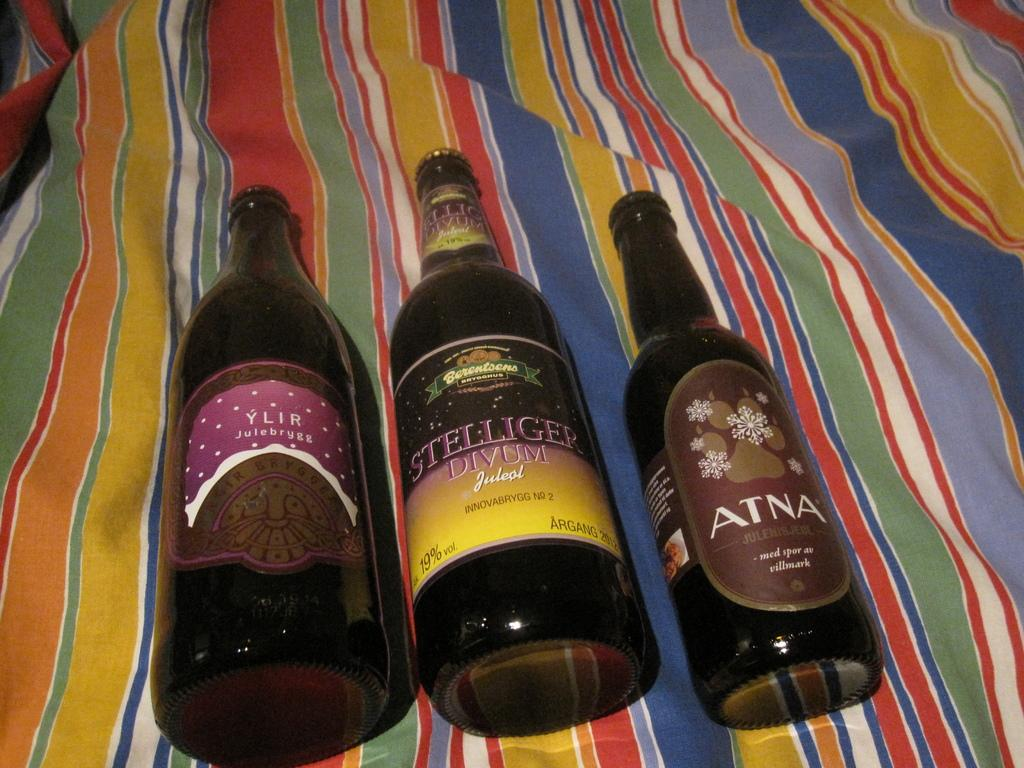<image>
Provide a brief description of the given image. Three bottles with Stelligur Divum in the middle. 